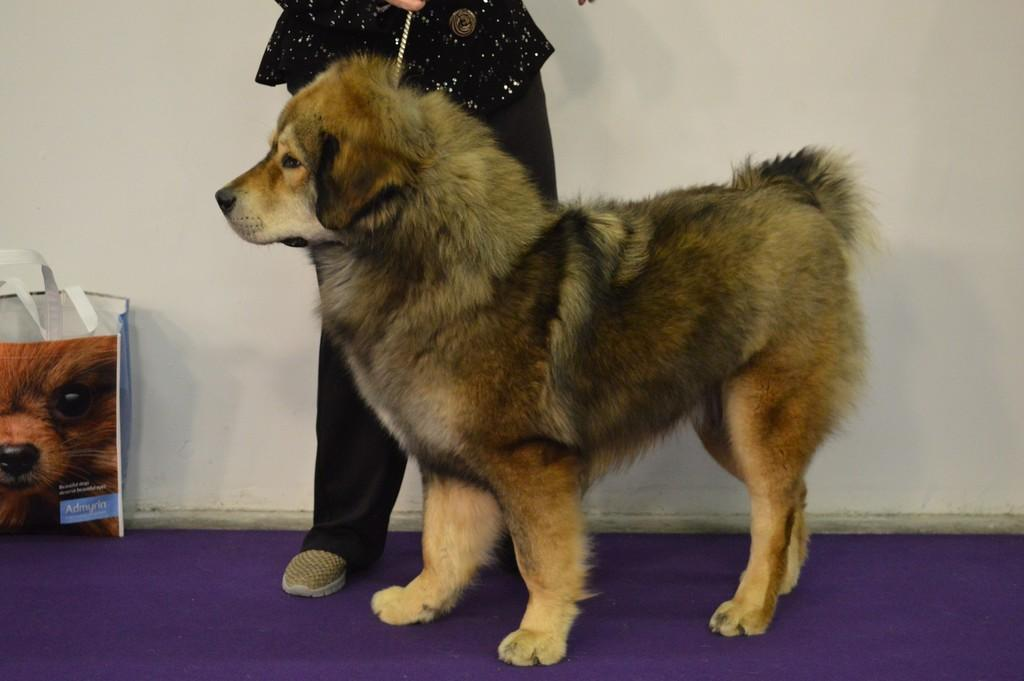What type of animal is on the floor in the image? There is a dog on the floor in the image. What object can be seen in addition to the dog? There is a bag in the image. Can you describe the person in the image? There is a person in the image. What is visible behind the person? There is a wall visible behind the person. How many cats are in the image? There are no cats present in the image. What type of flock can be seen flying in the background of the image? There is no flock visible in the image; it only features a dog, a bag, a person, and a wall. 